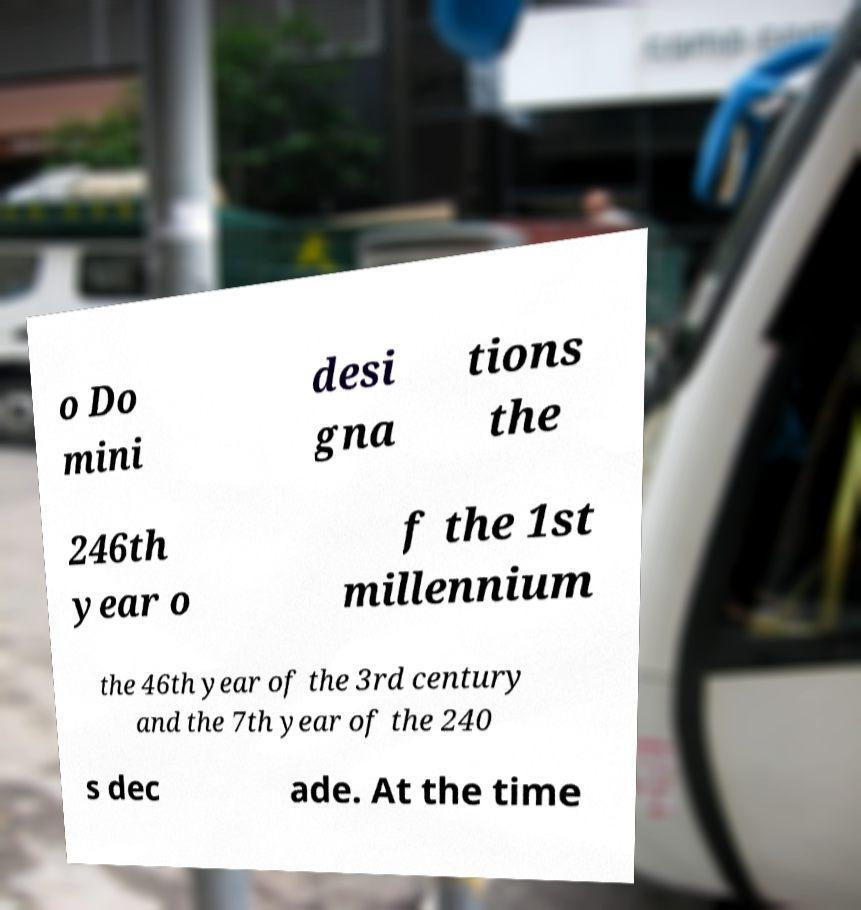There's text embedded in this image that I need extracted. Can you transcribe it verbatim? o Do mini desi gna tions the 246th year o f the 1st millennium the 46th year of the 3rd century and the 7th year of the 240 s dec ade. At the time 